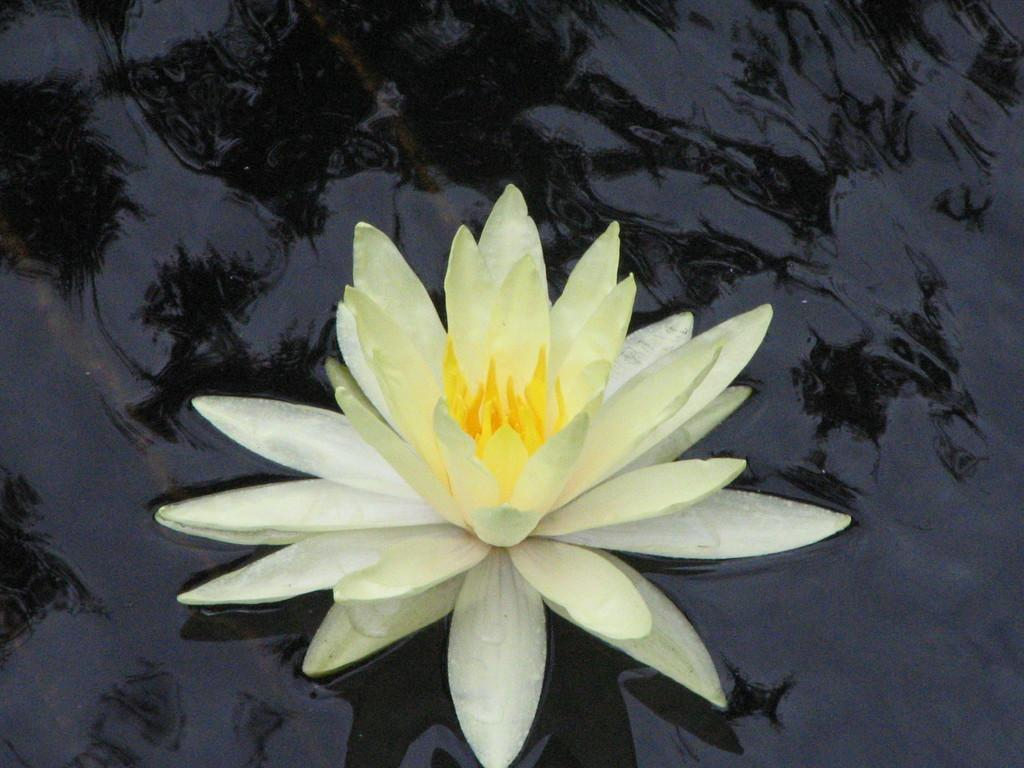What type of flowers are in the image? There are white and yellow lotus flowers in the image. Where are the lotus flowers located? The lotus flowers are in the water. What type of calendar is hanging on the wall in the image? There is no calendar present in the image; it features white and yellow lotus flowers in the water. 